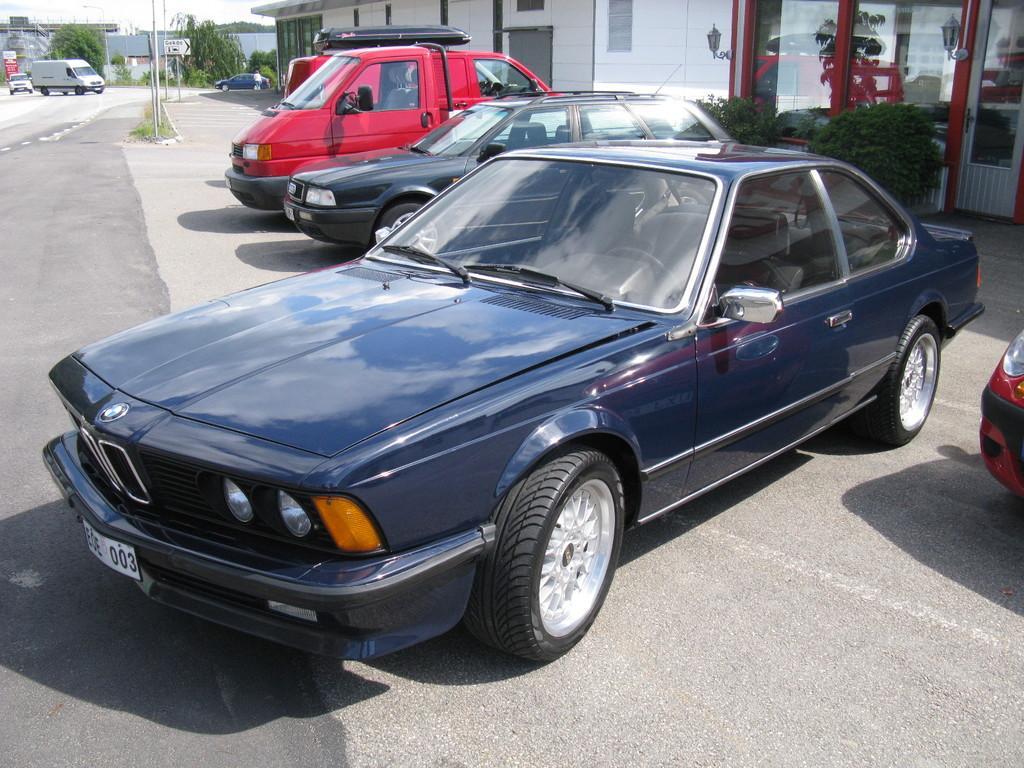Please provide a concise description of this image. In this picture we can see the vehicles, buildings, glass doors, plants, trees, poles, boards, lights, door. At the bottom of the image we can see the road. In the top let corner we can see the sky. 